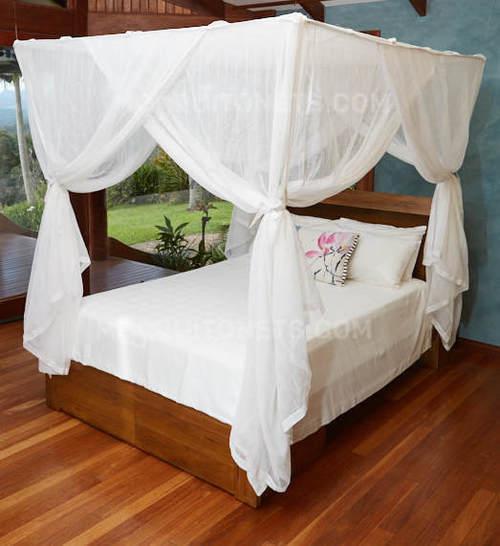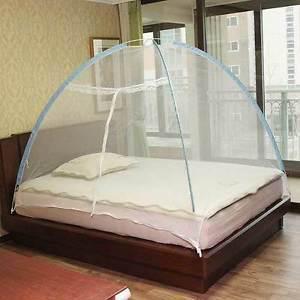The first image is the image on the left, the second image is the image on the right. Assess this claim about the two images: "One of the beds has two pillows.". Correct or not? Answer yes or no. No. The first image is the image on the left, the second image is the image on the right. Analyze the images presented: Is the assertion "One canopy is square shaped." valid? Answer yes or no. Yes. 